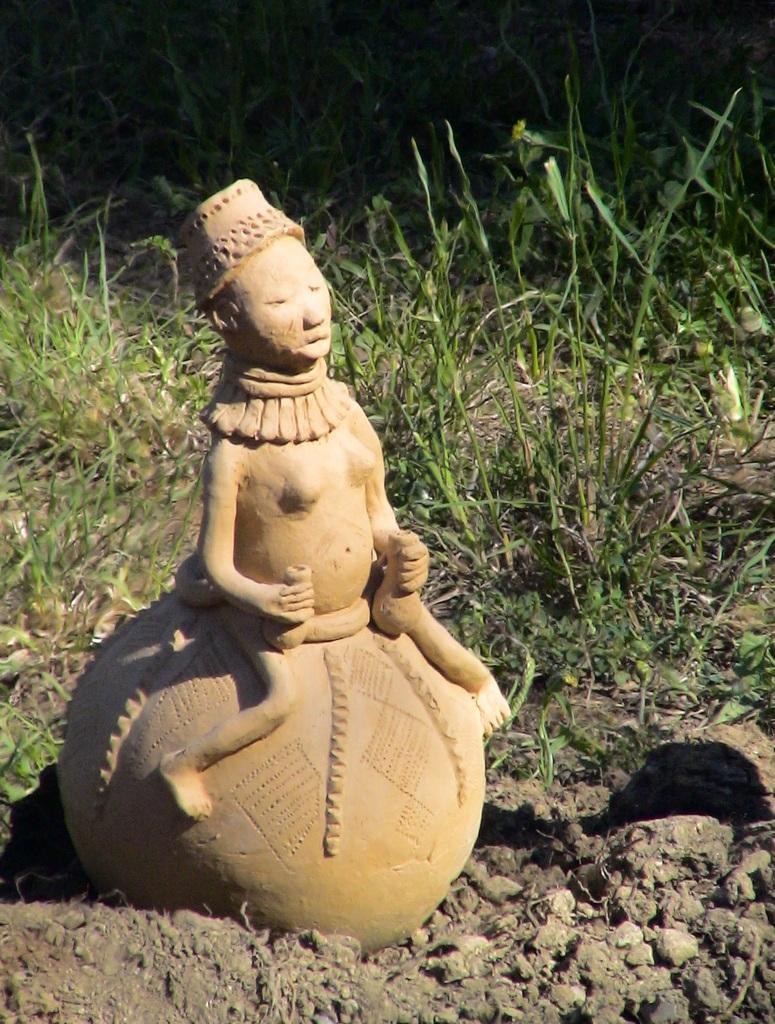What is the main subject of the image? There is a statue in the image. Where is the statue located? The statue is on the ground. What can be seen in the background of the image? There is grass visible in the background of the image. What type of chin can be seen on the statue in the image? There is no chin present on the statue in the image, as it is a statue and not a living being. 